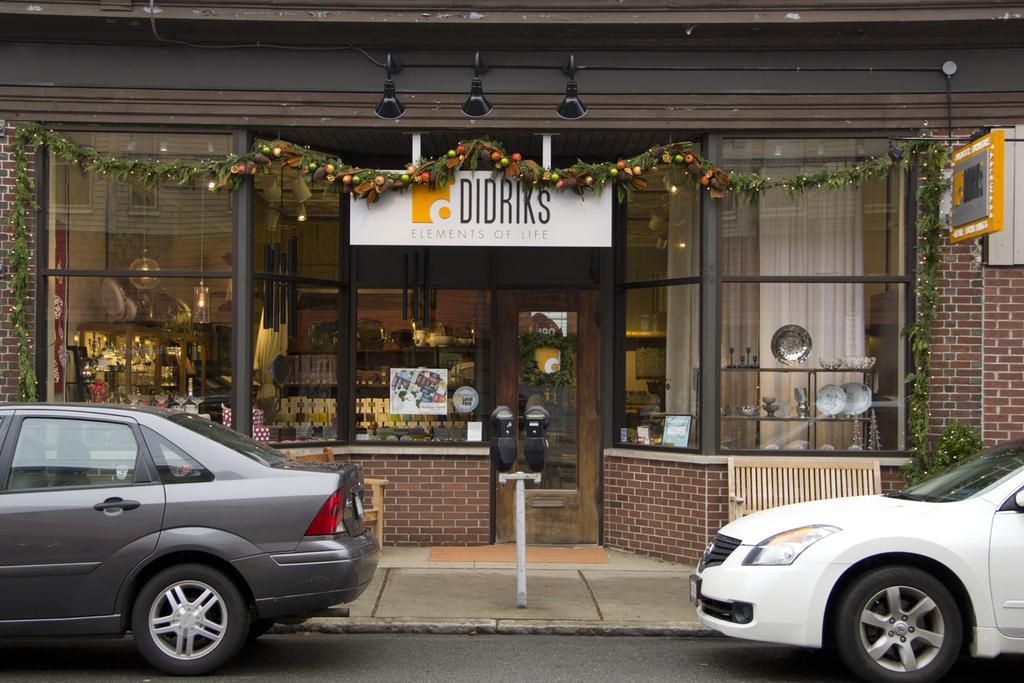In one or two sentences, can you explain what this image depicts? In this image I can see the vehicles on the road. To the side of the road I can see the pole and the building with boards and the glass doors. Through the glass I can see the plates, bowl and few objects in the shelves and I can see the frames to the wall and lights at the top. 